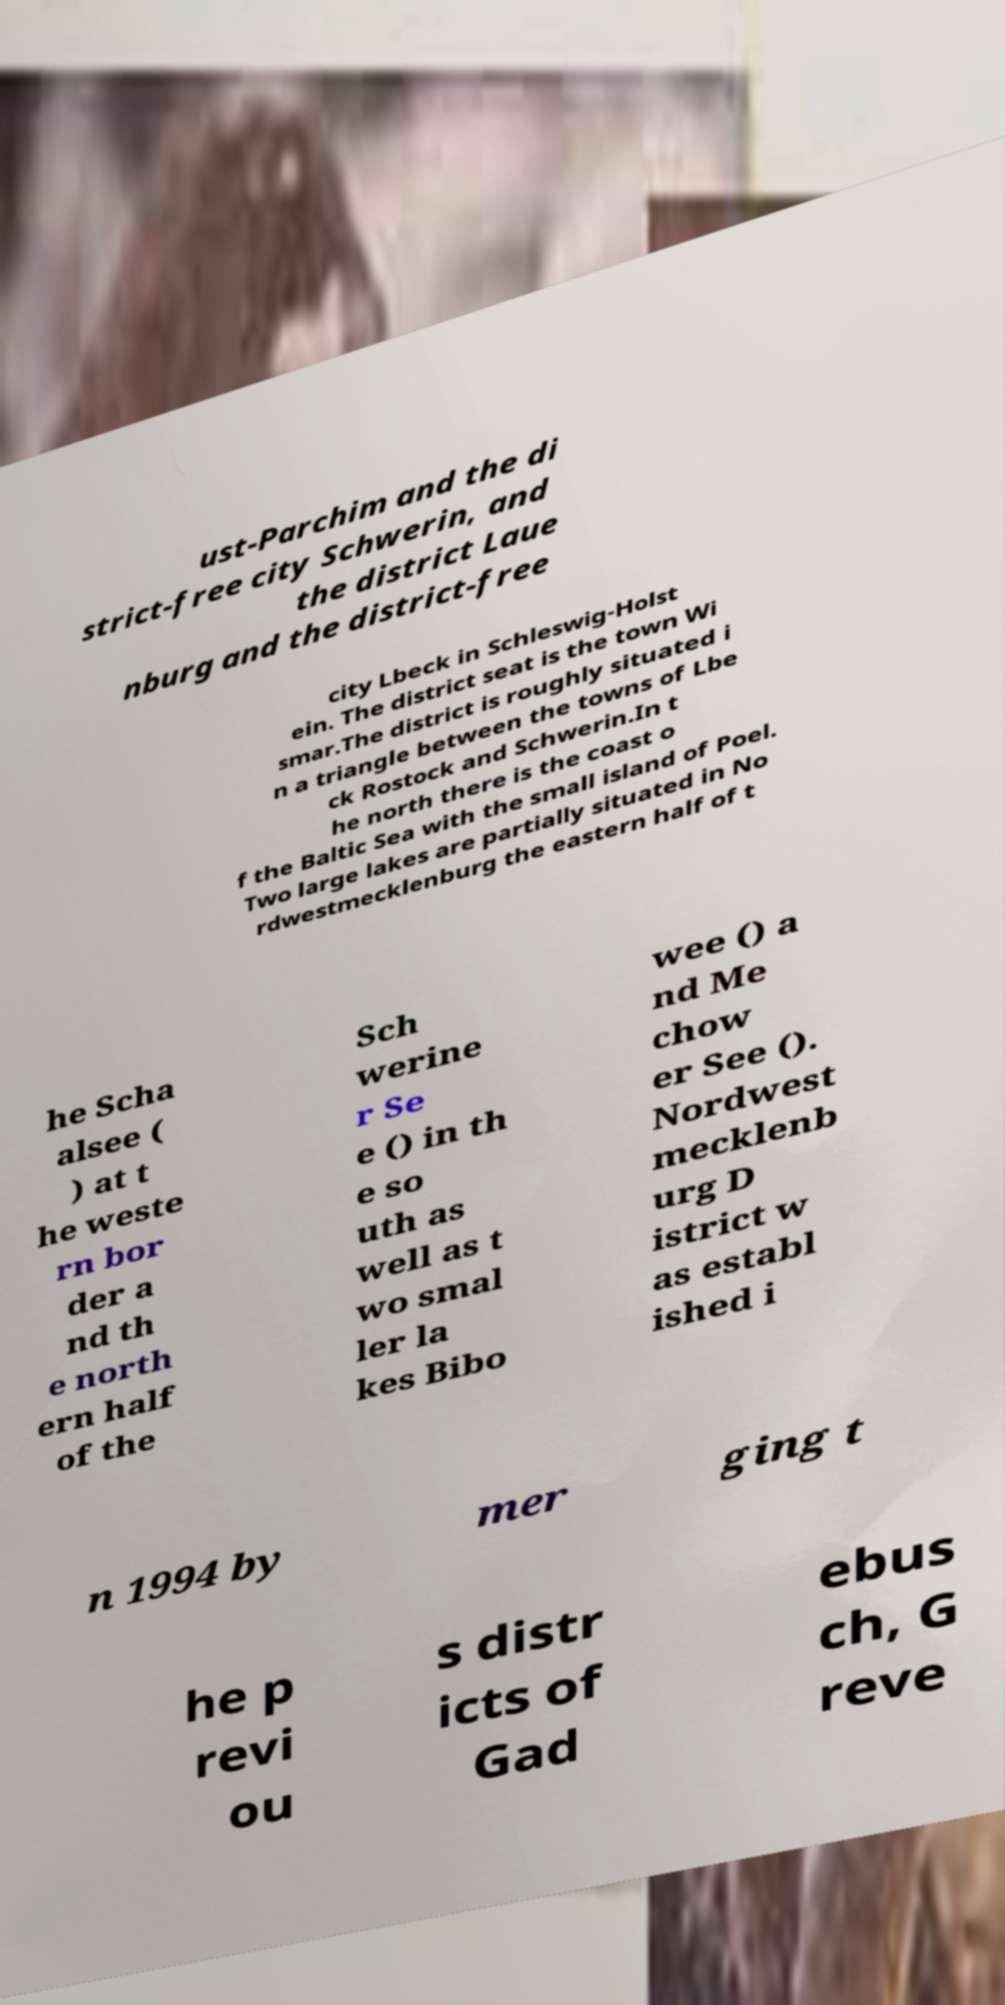What messages or text are displayed in this image? I need them in a readable, typed format. ust-Parchim and the di strict-free city Schwerin, and the district Laue nburg and the district-free city Lbeck in Schleswig-Holst ein. The district seat is the town Wi smar.The district is roughly situated i n a triangle between the towns of Lbe ck Rostock and Schwerin.In t he north there is the coast o f the Baltic Sea with the small island of Poel. Two large lakes are partially situated in No rdwestmecklenburg the eastern half of t he Scha alsee ( ) at t he weste rn bor der a nd th e north ern half of the Sch werine r Se e () in th e so uth as well as t wo smal ler la kes Bibo wee () a nd Me chow er See (). Nordwest mecklenb urg D istrict w as establ ished i n 1994 by mer ging t he p revi ou s distr icts of Gad ebus ch, G reve 